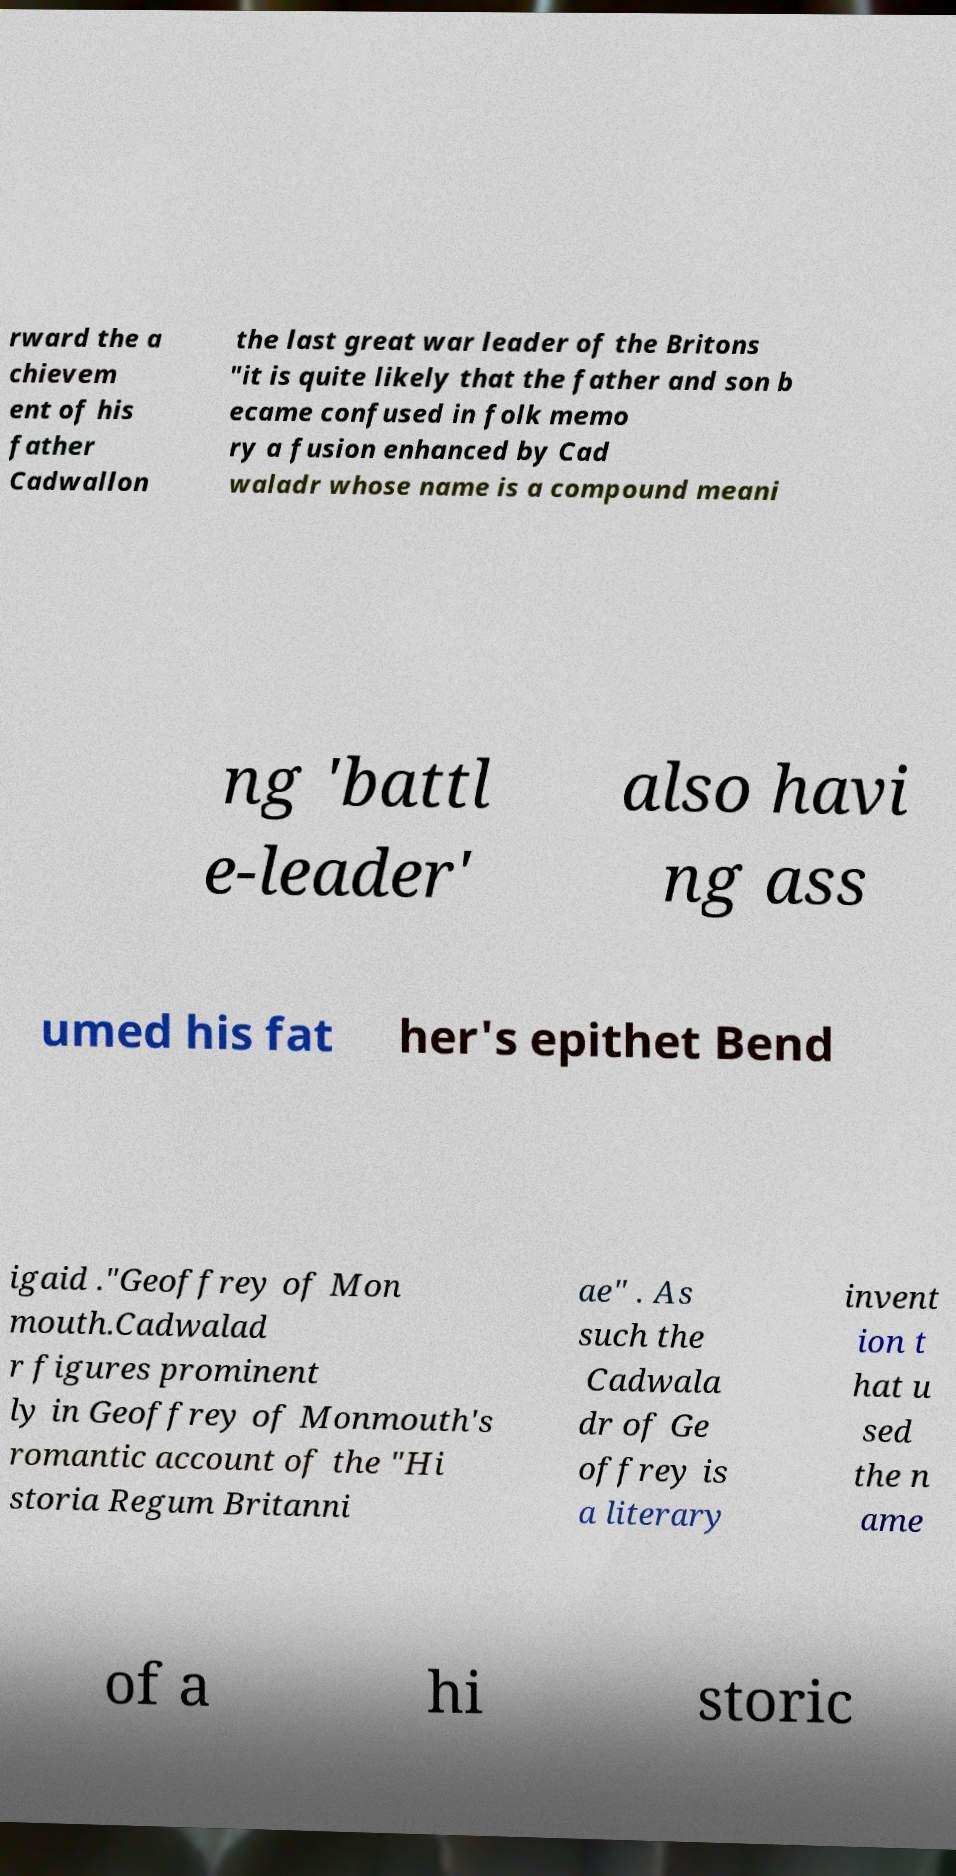Can you accurately transcribe the text from the provided image for me? rward the a chievem ent of his father Cadwallon the last great war leader of the Britons "it is quite likely that the father and son b ecame confused in folk memo ry a fusion enhanced by Cad waladr whose name is a compound meani ng 'battl e-leader' also havi ng ass umed his fat her's epithet Bend igaid ."Geoffrey of Mon mouth.Cadwalad r figures prominent ly in Geoffrey of Monmouth's romantic account of the "Hi storia Regum Britanni ae" . As such the Cadwala dr of Ge offrey is a literary invent ion t hat u sed the n ame of a hi storic 